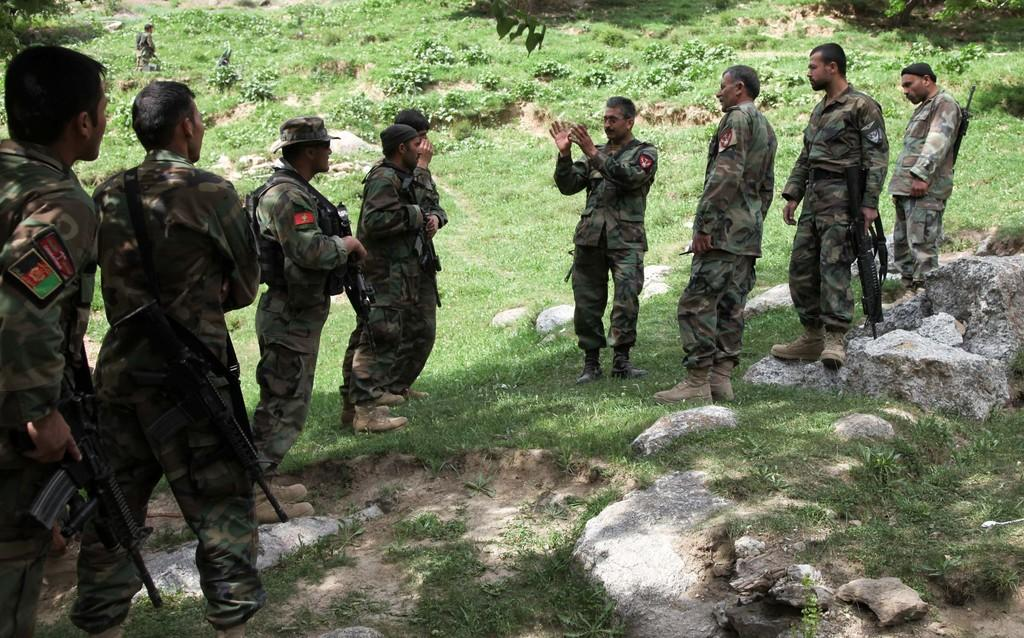What can be observed about the people in the image? There are people standing in the image, and they are wearing uniforms. Are the people carrying anything in the image? Some of the people are carrying guns in the image. What type of terrain is visible in the image? There is grass visible in the image. What else can be seen in the image besides the people and grass? Shadows are present in the image. What type of board is being used by the people in the image? There is no board present in the image; the people are standing and carrying guns. Can you describe the shock experienced by the people in the image? There is no indication of shock or any emotional state in the image; the people are simply standing and carrying guns. 